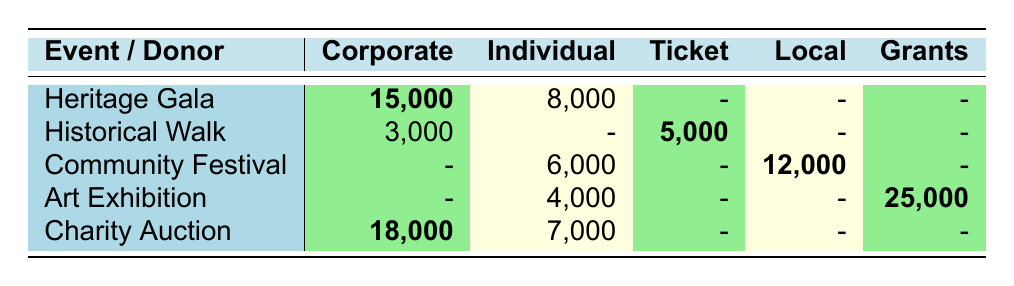What is the total revenue from the Heritage Gala? The revenue for the Heritage Gala includes contributions from Corporate Sponsors (15,000) and Individual Donors (8,000). Adding these amounts gives: 15,000 + 8,000 = 23,000.
Answer: 23,000 Which fundraising event had the highest revenue from Corporate Sponsors? By examining the Corporate column, Heritage Gala had 15,000, Historical Walk had 3,000, Community Festival had 0, Art Exhibition had 0, and Charity Auction had 18,000. The highest amount is from Charity Auction (18,000).
Answer: Charity Auction True or False: Individual Donors contributed more to the Community Festival than to any other event. The total revenue from Individual Donors for the Community Festival is 6,000. Comparing this with other events: Heritage Gala (8,000), Historical Walk (0), Art Exhibition (4,000), and Charity Auction (7,000), the individual donors’ contribution to the Community Festival is not more than those for the Heritage Gala or Charity Auction, so the statement is false.
Answer: False What is the total revenue generated from Grants across all events? Grants are only reported in the Art Exhibition with 25,000 in revenue. Hence, the total revenue from Grants is 25,000.
Answer: 25,000 Which event brought in the least revenue from ticket sales? Ticket sales are only recorded for the Historical Walk, which has 5,000. Since it is the only event with ticket sales, it also has the least revenue from this category.
Answer: Historical Walk What is the overall total revenue from all events? Summing all listed revenues: Heritage Gala (23,000) + Historical Walk (8,000) + Community Festival (18,000) + Art Exhibition (25,000) + Charity Auction (25,000) gives 23,000 + 5,000 + 12,000 + 25,000 + 25,000 = 93,000.
Answer: 93,000 Did Corporate Sponsors contribute a higher total revenue compared to Local Businesses? Corporate Sponsors contributed a total from various events: Heritage Gala (15,000), Historical Walk (3,000), Charity Auction (18,000), totaling 36,000. Local Businesses only contributed during the Community Festival, which is 12,000. Since 36,000 is higher than 12,000, the answer is yes.
Answer: Yes Which donor category received the lowest total revenue across all events? The donor category with the lowest total revenue can be calculated: Corporate Sponsors (36,000), Individual Donors (25,000), Ticket Sales (5,000), Local Businesses (12,000), and Grants (25,000). The lowest value is Ticket Sales at 5,000.
Answer: Ticket Sales 